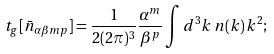Convert formula to latex. <formula><loc_0><loc_0><loc_500><loc_500>t _ { g } [ \bar { n } _ { \alpha \beta m p } ] = \frac { 1 } { 2 ( 2 \pi ) ^ { 3 } } \frac { \alpha ^ { m } } { \beta ^ { p } } \int d ^ { 3 } k \, n ( k ) \, k ^ { 2 } ;</formula> 